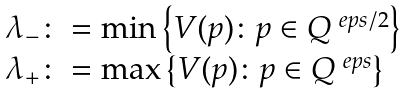<formula> <loc_0><loc_0><loc_500><loc_500>\begin{array} { l } \lambda _ { - } \colon = \min \left \{ V ( p ) \colon p \in Q ^ { \ e p s / 2 } \right \} \\ \lambda _ { + } \colon = \max \left \{ V ( p ) \colon p \in Q ^ { \ e p s } \right \} \end{array}</formula> 